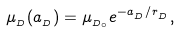Convert formula to latex. <formula><loc_0><loc_0><loc_500><loc_500>\mu _ { _ { D } } ( a _ { _ { D } } ) = \mu _ { _ { D _ { \circ } } } e ^ { - { a _ { _ { D } } } / { r _ { _ { D } } } } ,</formula> 